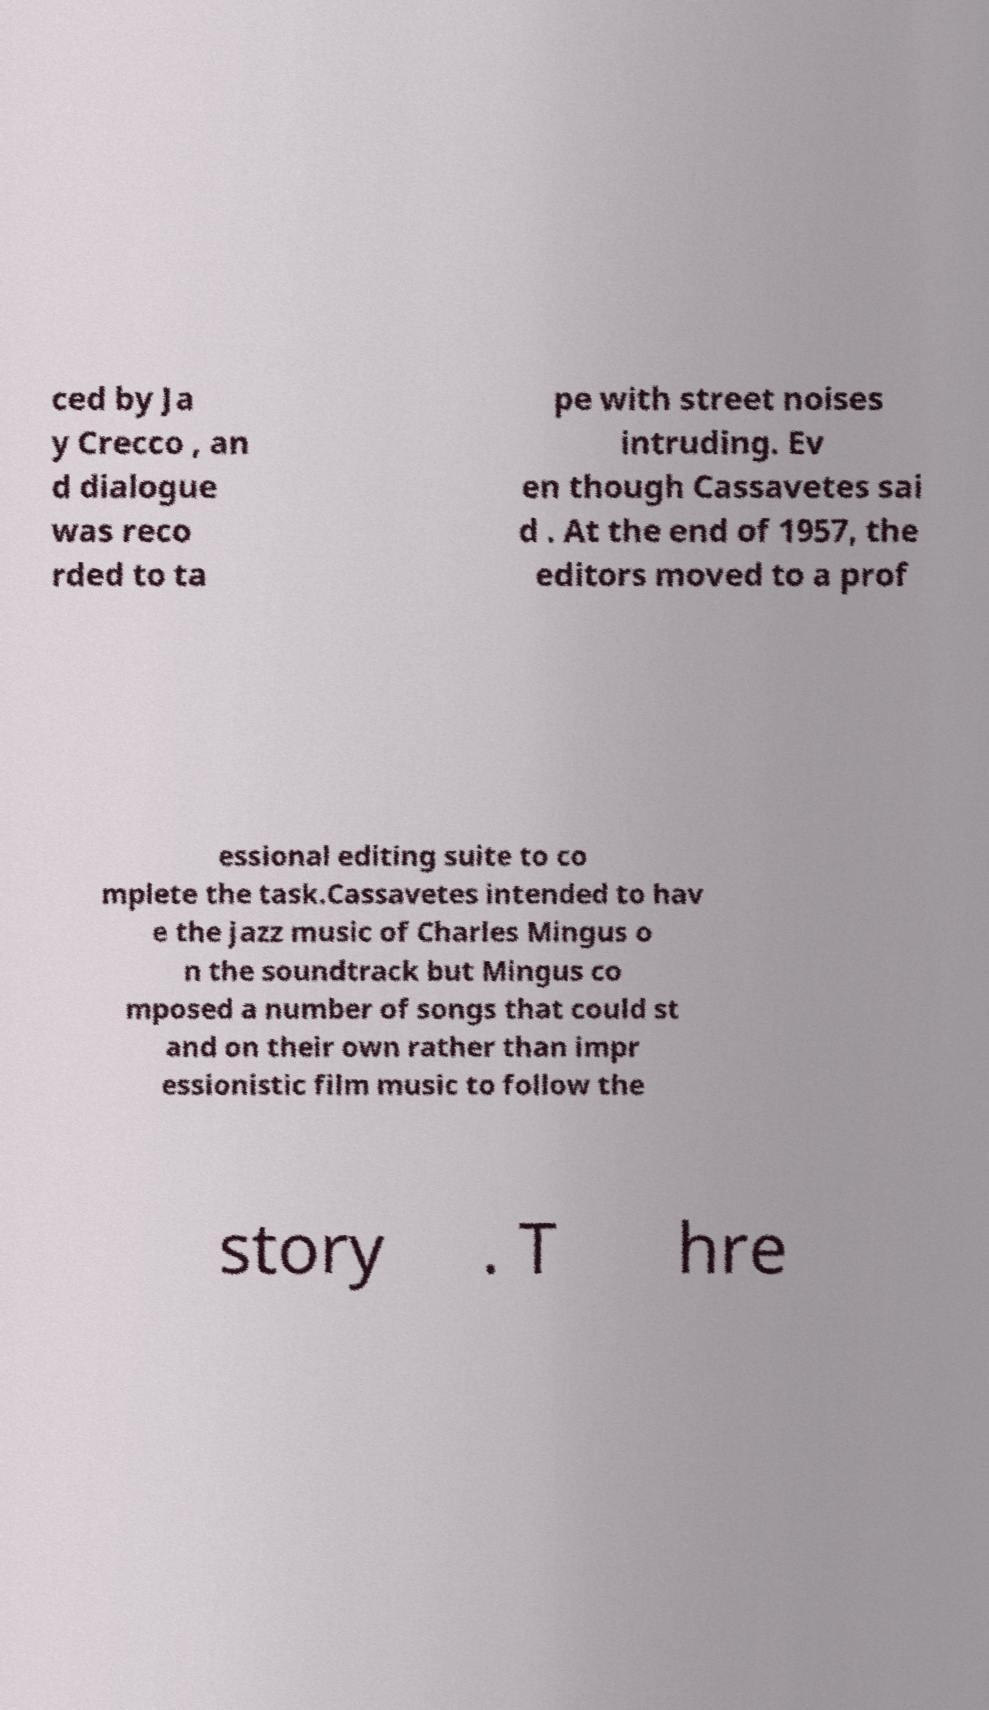Can you accurately transcribe the text from the provided image for me? ced by Ja y Crecco , an d dialogue was reco rded to ta pe with street noises intruding. Ev en though Cassavetes sai d . At the end of 1957, the editors moved to a prof essional editing suite to co mplete the task.Cassavetes intended to hav e the jazz music of Charles Mingus o n the soundtrack but Mingus co mposed a number of songs that could st and on their own rather than impr essionistic film music to follow the story . T hre 